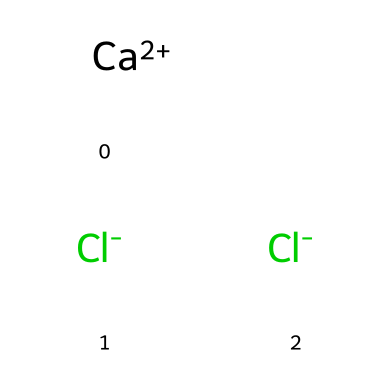What is the common name of this chemical? The chemical structure corresponds to calcium chloride, which is commonly used for de-icing roads. This is derived from identifying the central element (calcium) and the two chloride ions surrounding it.
Answer: calcium chloride How many chlorine atoms are present in this compound? The SMILES representation has two separate instances of chloride ions, indicating that there are two chlorine atoms in the overall structure.
Answer: two What is the charge of the calcium ion in this formula? In the SMILES, "Ca+2" indicates that the calcium ion carries a +2 charge, which is crucial for its interaction with the negatively charged chloride ions.
Answer: +2 What is the total number of atoms in this compound? The representation displays one calcium atom and two chloride atoms, totaling three atoms when combined.
Answer: three What type of electrolyte is calcium chloride categorized as? Calcium chloride is known as a strong electrolyte because it dissociates completely into its ions in solution. This classification comes from its ability to conduct electricity efficiently when dissolved.
Answer: strong electrolyte What effect does this chemical have on freezing point depression? Calcium chloride lowers the freezing point of water more effectively than common salt due to its higher dissociation into ions (Ca²⁺ and 2Cl⁻), enhancing its ability to disrupt the formation of ice.
Answer: freezing point depression 